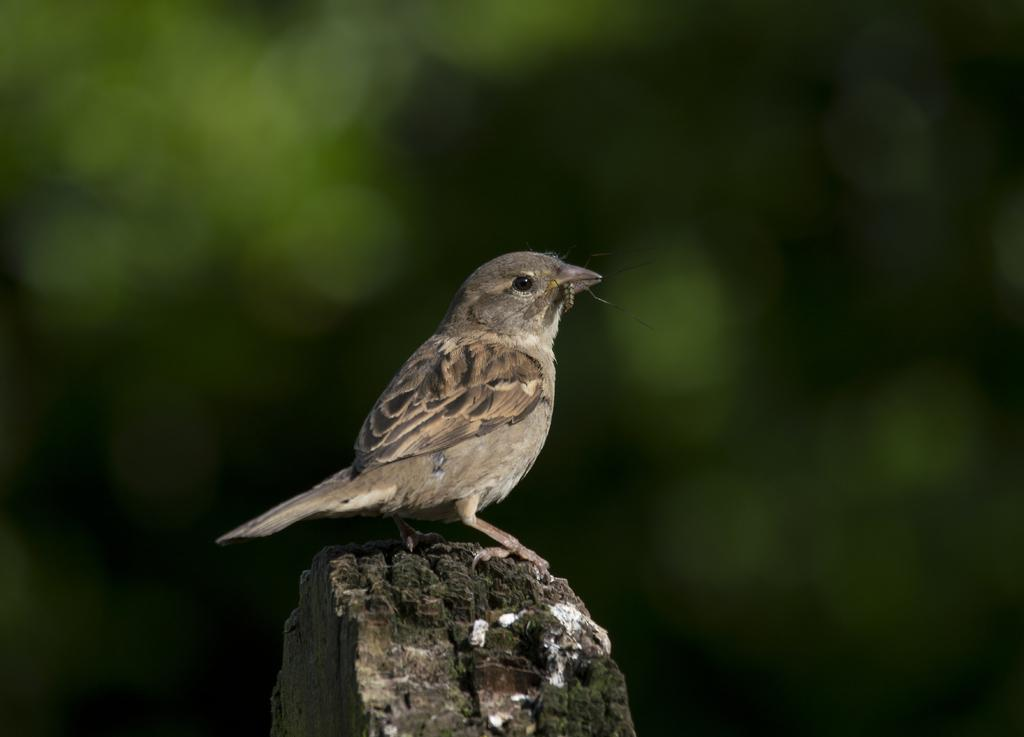What type of bird is in the image? There is a sparrow in the image. Can you describe the background of the image? The background of the image is blurred. What type of feast is being prepared in the image? There is no feast or any indication of food preparation in the image; it only features a sparrow. 